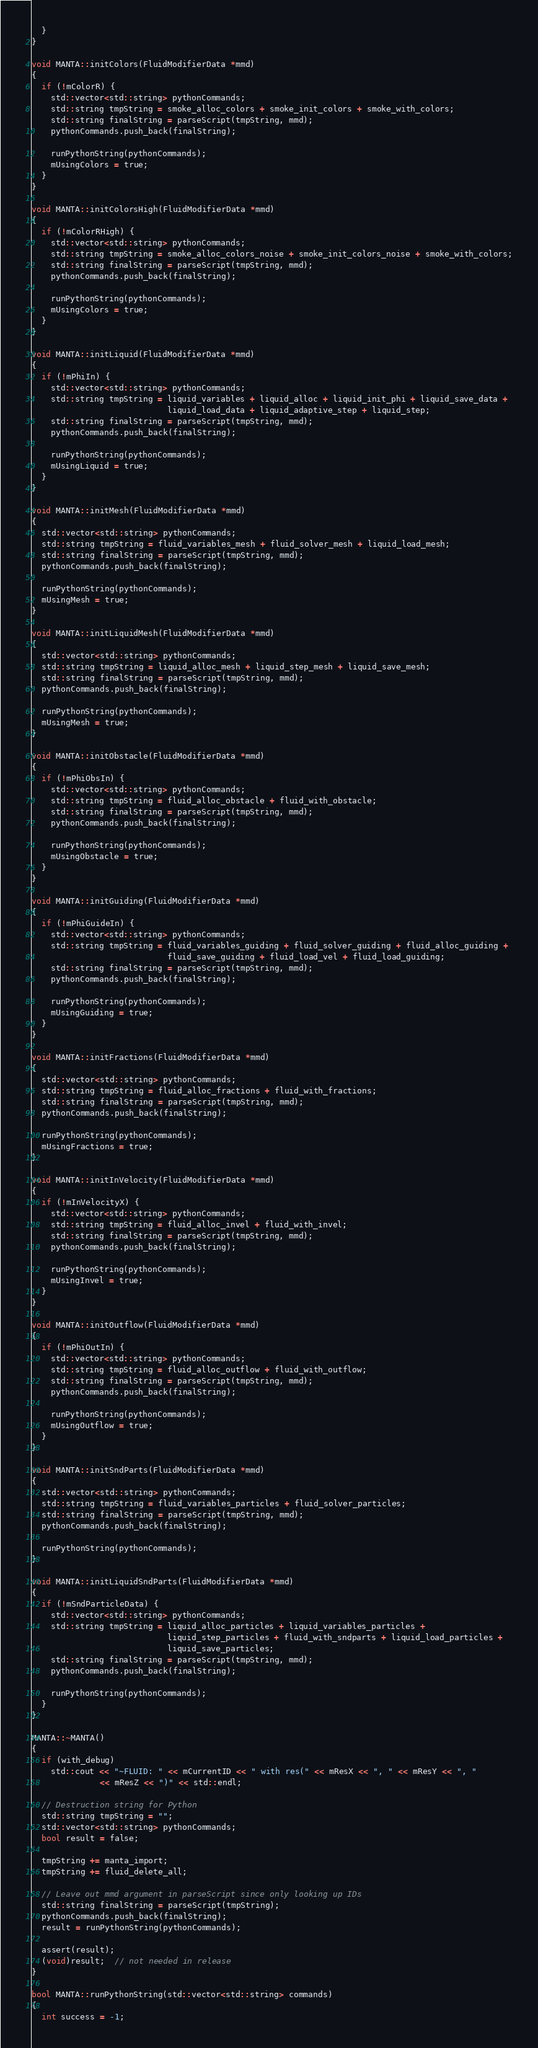<code> <loc_0><loc_0><loc_500><loc_500><_C++_>  }
}

void MANTA::initColors(FluidModifierData *mmd)
{
  if (!mColorR) {
    std::vector<std::string> pythonCommands;
    std::string tmpString = smoke_alloc_colors + smoke_init_colors + smoke_with_colors;
    std::string finalString = parseScript(tmpString, mmd);
    pythonCommands.push_back(finalString);

    runPythonString(pythonCommands);
    mUsingColors = true;
  }
}

void MANTA::initColorsHigh(FluidModifierData *mmd)
{
  if (!mColorRHigh) {
    std::vector<std::string> pythonCommands;
    std::string tmpString = smoke_alloc_colors_noise + smoke_init_colors_noise + smoke_with_colors;
    std::string finalString = parseScript(tmpString, mmd);
    pythonCommands.push_back(finalString);

    runPythonString(pythonCommands);
    mUsingColors = true;
  }
}

void MANTA::initLiquid(FluidModifierData *mmd)
{
  if (!mPhiIn) {
    std::vector<std::string> pythonCommands;
    std::string tmpString = liquid_variables + liquid_alloc + liquid_init_phi + liquid_save_data +
                            liquid_load_data + liquid_adaptive_step + liquid_step;
    std::string finalString = parseScript(tmpString, mmd);
    pythonCommands.push_back(finalString);

    runPythonString(pythonCommands);
    mUsingLiquid = true;
  }
}

void MANTA::initMesh(FluidModifierData *mmd)
{
  std::vector<std::string> pythonCommands;
  std::string tmpString = fluid_variables_mesh + fluid_solver_mesh + liquid_load_mesh;
  std::string finalString = parseScript(tmpString, mmd);
  pythonCommands.push_back(finalString);

  runPythonString(pythonCommands);
  mUsingMesh = true;
}

void MANTA::initLiquidMesh(FluidModifierData *mmd)
{
  std::vector<std::string> pythonCommands;
  std::string tmpString = liquid_alloc_mesh + liquid_step_mesh + liquid_save_mesh;
  std::string finalString = parseScript(tmpString, mmd);
  pythonCommands.push_back(finalString);

  runPythonString(pythonCommands);
  mUsingMesh = true;
}

void MANTA::initObstacle(FluidModifierData *mmd)
{
  if (!mPhiObsIn) {
    std::vector<std::string> pythonCommands;
    std::string tmpString = fluid_alloc_obstacle + fluid_with_obstacle;
    std::string finalString = parseScript(tmpString, mmd);
    pythonCommands.push_back(finalString);

    runPythonString(pythonCommands);
    mUsingObstacle = true;
  }
}

void MANTA::initGuiding(FluidModifierData *mmd)
{
  if (!mPhiGuideIn) {
    std::vector<std::string> pythonCommands;
    std::string tmpString = fluid_variables_guiding + fluid_solver_guiding + fluid_alloc_guiding +
                            fluid_save_guiding + fluid_load_vel + fluid_load_guiding;
    std::string finalString = parseScript(tmpString, mmd);
    pythonCommands.push_back(finalString);

    runPythonString(pythonCommands);
    mUsingGuiding = true;
  }
}

void MANTA::initFractions(FluidModifierData *mmd)
{
  std::vector<std::string> pythonCommands;
  std::string tmpString = fluid_alloc_fractions + fluid_with_fractions;
  std::string finalString = parseScript(tmpString, mmd);
  pythonCommands.push_back(finalString);

  runPythonString(pythonCommands);
  mUsingFractions = true;
}

void MANTA::initInVelocity(FluidModifierData *mmd)
{
  if (!mInVelocityX) {
    std::vector<std::string> pythonCommands;
    std::string tmpString = fluid_alloc_invel + fluid_with_invel;
    std::string finalString = parseScript(tmpString, mmd);
    pythonCommands.push_back(finalString);

    runPythonString(pythonCommands);
    mUsingInvel = true;
  }
}

void MANTA::initOutflow(FluidModifierData *mmd)
{
  if (!mPhiOutIn) {
    std::vector<std::string> pythonCommands;
    std::string tmpString = fluid_alloc_outflow + fluid_with_outflow;
    std::string finalString = parseScript(tmpString, mmd);
    pythonCommands.push_back(finalString);

    runPythonString(pythonCommands);
    mUsingOutflow = true;
  }
}

void MANTA::initSndParts(FluidModifierData *mmd)
{
  std::vector<std::string> pythonCommands;
  std::string tmpString = fluid_variables_particles + fluid_solver_particles;
  std::string finalString = parseScript(tmpString, mmd);
  pythonCommands.push_back(finalString);

  runPythonString(pythonCommands);
}

void MANTA::initLiquidSndParts(FluidModifierData *mmd)
{
  if (!mSndParticleData) {
    std::vector<std::string> pythonCommands;
    std::string tmpString = liquid_alloc_particles + liquid_variables_particles +
                            liquid_step_particles + fluid_with_sndparts + liquid_load_particles +
                            liquid_save_particles;
    std::string finalString = parseScript(tmpString, mmd);
    pythonCommands.push_back(finalString);

    runPythonString(pythonCommands);
  }
}

MANTA::~MANTA()
{
  if (with_debug)
    std::cout << "~FLUID: " << mCurrentID << " with res(" << mResX << ", " << mResY << ", "
              << mResZ << ")" << std::endl;

  // Destruction string for Python
  std::string tmpString = "";
  std::vector<std::string> pythonCommands;
  bool result = false;

  tmpString += manta_import;
  tmpString += fluid_delete_all;

  // Leave out mmd argument in parseScript since only looking up IDs
  std::string finalString = parseScript(tmpString);
  pythonCommands.push_back(finalString);
  result = runPythonString(pythonCommands);

  assert(result);
  (void)result;  // not needed in release
}

bool MANTA::runPythonString(std::vector<std::string> commands)
{
  int success = -1;</code> 